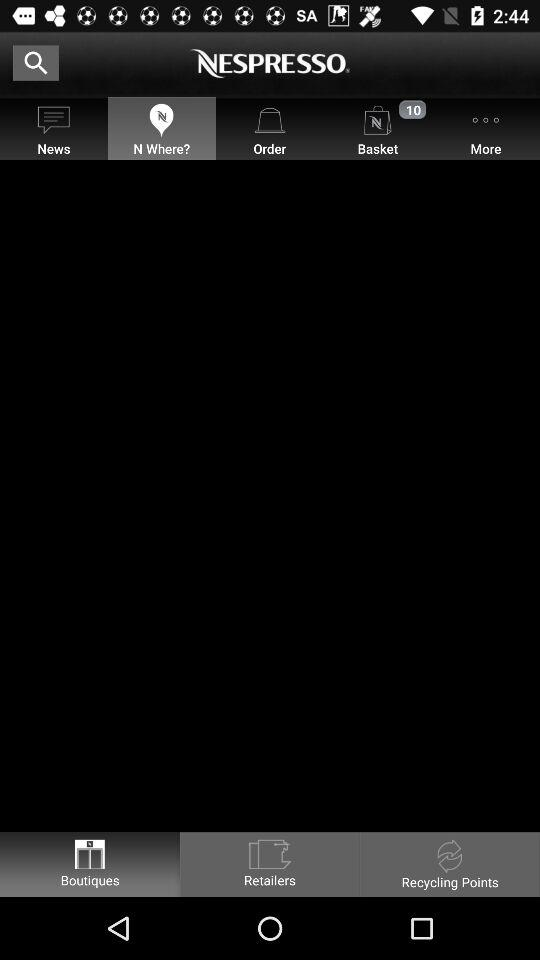On which tab am I now? You are on the "N Where?" tab. 